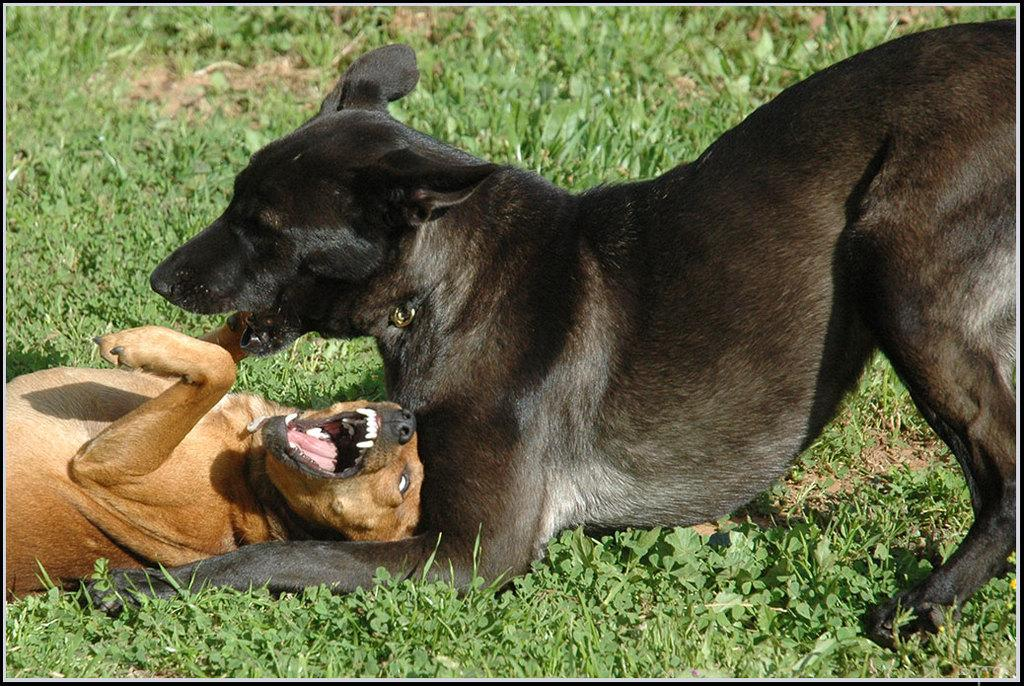What type of animals can be seen in the image? There are two dogs in the image, one black and one brown. Where is each dog located in the image? The black dog is on the right side of the image, and the brown dog is on the left side of the image. What is present at the bottom of the image? There are plants at the bottom of the image. What type of science experiment can be seen in the image? There is no science experiment present in the image; it features two dogs and plants. What type of teeth can be seen in the image? There are no teeth visible in the image, as it features dogs and plants. 